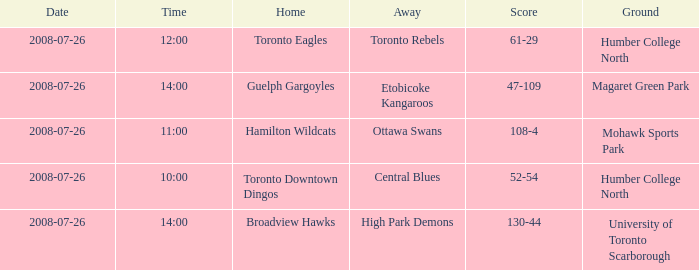When did the High Park Demons play Away? 2008-07-26. Give me the full table as a dictionary. {'header': ['Date', 'Time', 'Home', 'Away', 'Score', 'Ground'], 'rows': [['2008-07-26', '12:00', 'Toronto Eagles', 'Toronto Rebels', '61-29', 'Humber College North'], ['2008-07-26', '14:00', 'Guelph Gargoyles', 'Etobicoke Kangaroos', '47-109', 'Magaret Green Park'], ['2008-07-26', '11:00', 'Hamilton Wildcats', 'Ottawa Swans', '108-4', 'Mohawk Sports Park'], ['2008-07-26', '10:00', 'Toronto Downtown Dingos', 'Central Blues', '52-54', 'Humber College North'], ['2008-07-26', '14:00', 'Broadview Hawks', 'High Park Demons', '130-44', 'University of Toronto Scarborough']]} 